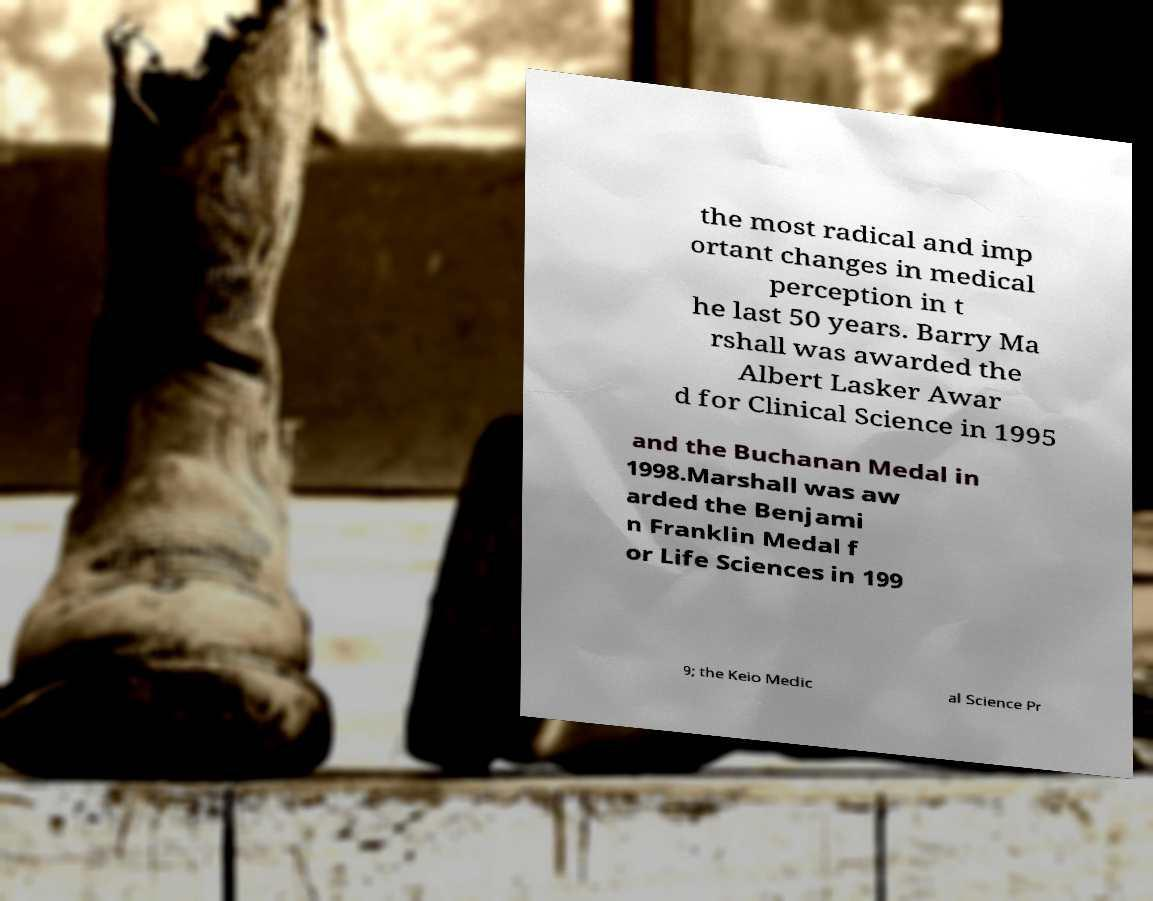Could you extract and type out the text from this image? the most radical and imp ortant changes in medical perception in t he last 50 years. Barry Ma rshall was awarded the Albert Lasker Awar d for Clinical Science in 1995 and the Buchanan Medal in 1998.Marshall was aw arded the Benjami n Franklin Medal f or Life Sciences in 199 9; the Keio Medic al Science Pr 